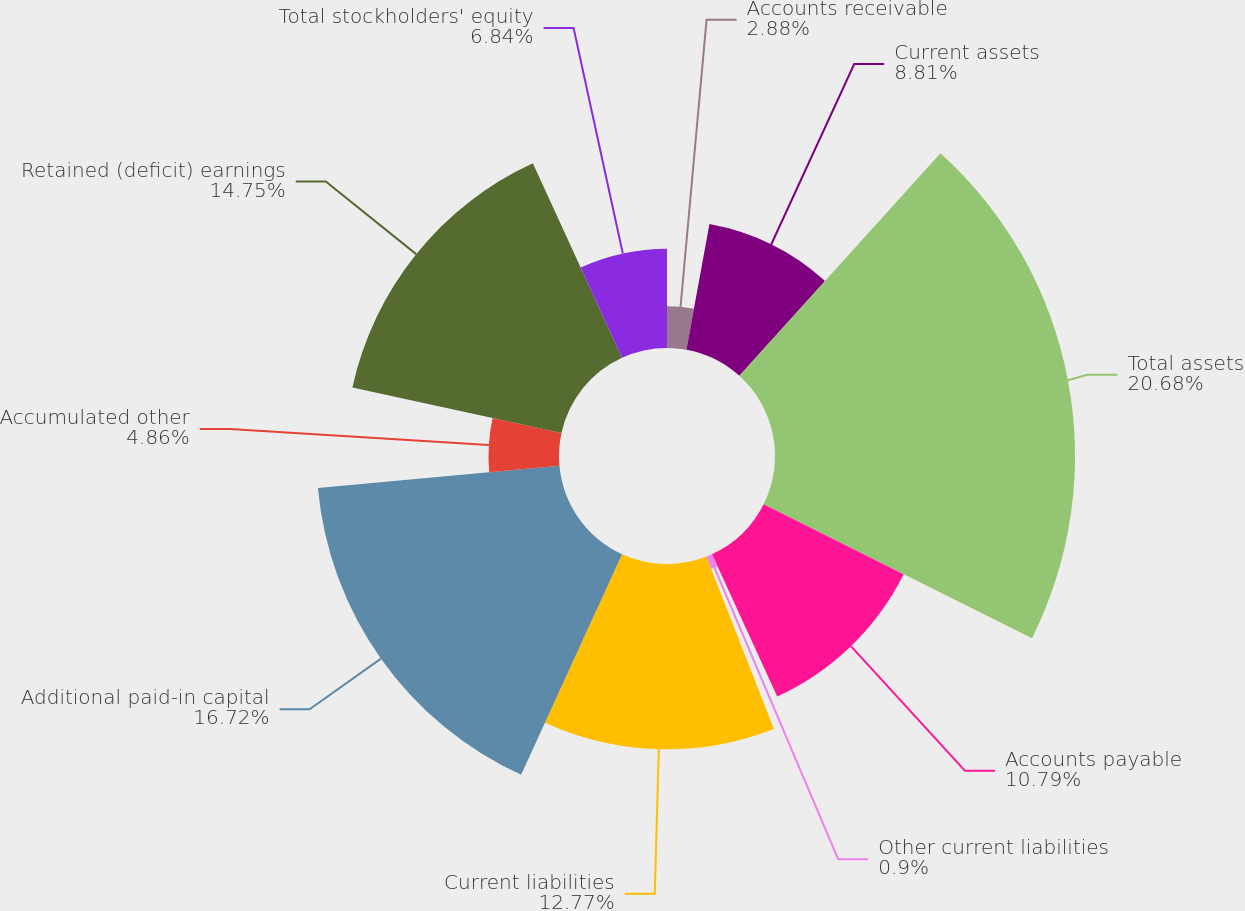<chart> <loc_0><loc_0><loc_500><loc_500><pie_chart><fcel>Accounts receivable<fcel>Current assets<fcel>Total assets<fcel>Accounts payable<fcel>Other current liabilities<fcel>Current liabilities<fcel>Additional paid-in capital<fcel>Accumulated other<fcel>Retained (deficit) earnings<fcel>Total stockholders' equity<nl><fcel>2.88%<fcel>8.81%<fcel>20.68%<fcel>10.79%<fcel>0.9%<fcel>12.77%<fcel>16.72%<fcel>4.86%<fcel>14.75%<fcel>6.84%<nl></chart> 